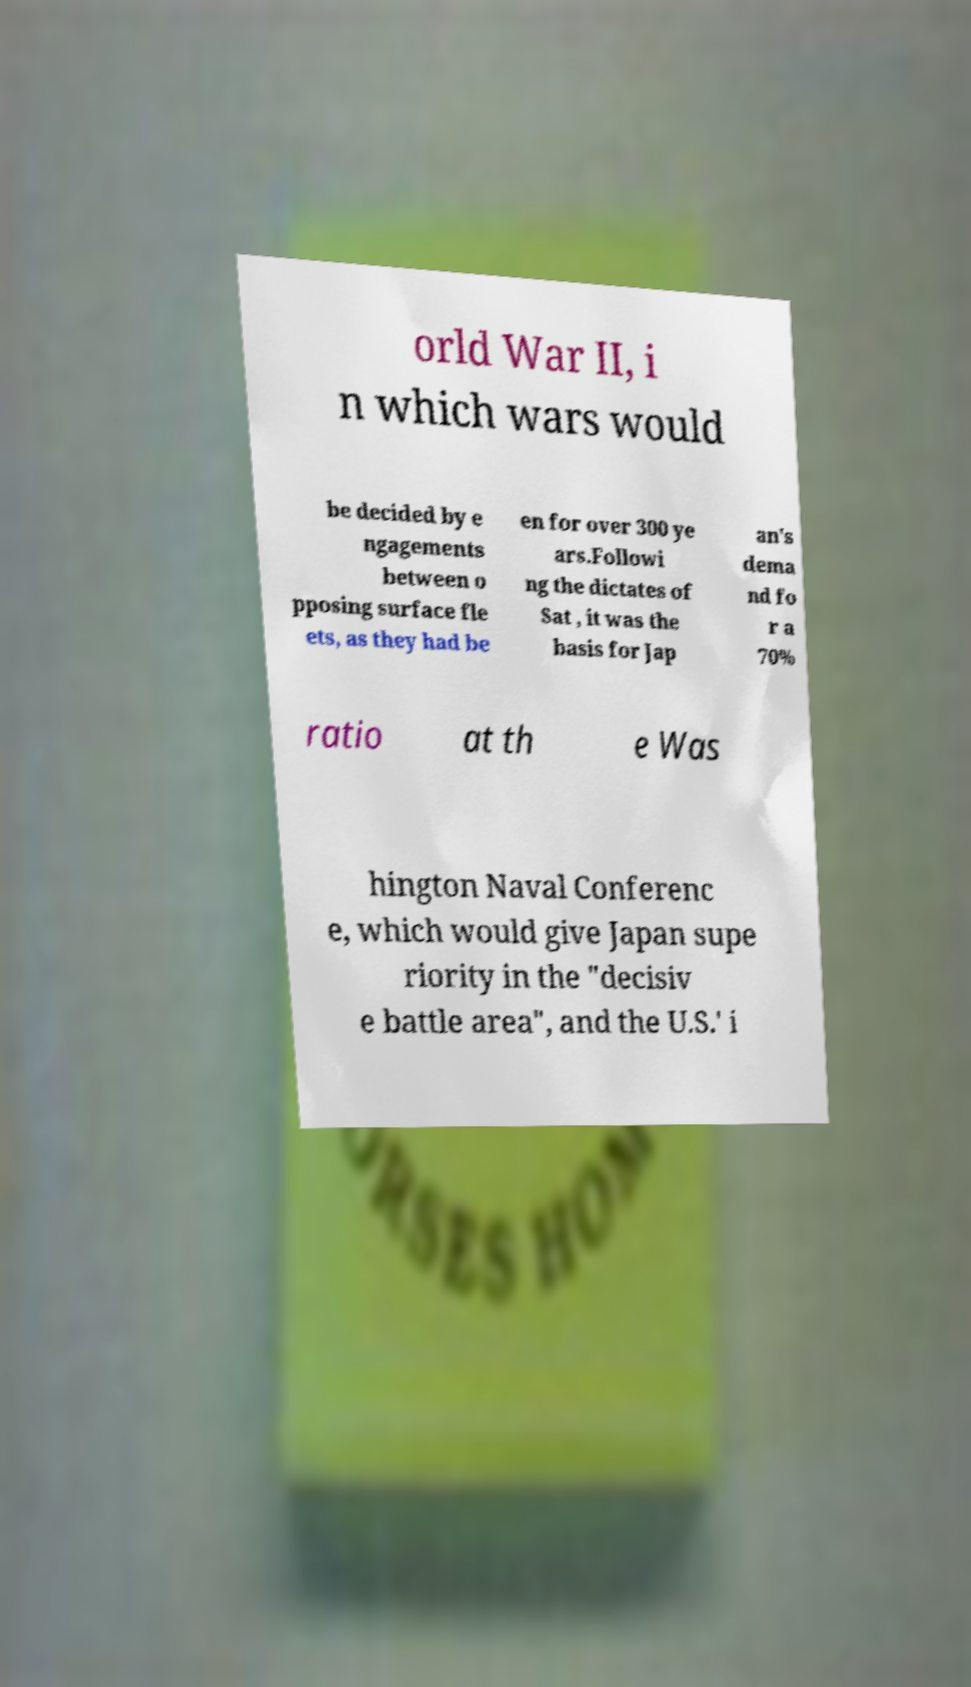Please identify and transcribe the text found in this image. orld War II, i n which wars would be decided by e ngagements between o pposing surface fle ets, as they had be en for over 300 ye ars.Followi ng the dictates of Sat , it was the basis for Jap an's dema nd fo r a 70% ratio at th e Was hington Naval Conferenc e, which would give Japan supe riority in the "decisiv e battle area", and the U.S.' i 